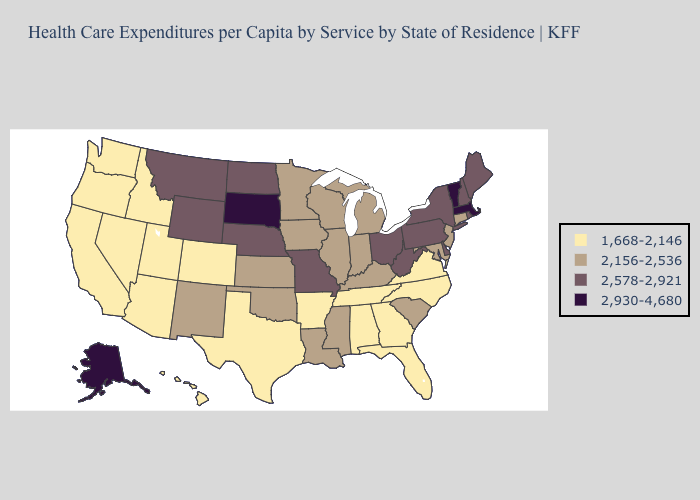Among the states that border Georgia , does South Carolina have the lowest value?
Give a very brief answer. No. What is the highest value in the USA?
Write a very short answer. 2,930-4,680. Does the first symbol in the legend represent the smallest category?
Keep it brief. Yes. Does New Jersey have the lowest value in the Northeast?
Answer briefly. Yes. Does Iowa have the lowest value in the USA?
Concise answer only. No. What is the lowest value in the USA?
Give a very brief answer. 1,668-2,146. What is the value of Oklahoma?
Write a very short answer. 2,156-2,536. What is the value of California?
Concise answer only. 1,668-2,146. Name the states that have a value in the range 1,668-2,146?
Be succinct. Alabama, Arizona, Arkansas, California, Colorado, Florida, Georgia, Hawaii, Idaho, Nevada, North Carolina, Oregon, Tennessee, Texas, Utah, Virginia, Washington. Name the states that have a value in the range 2,578-2,921?
Concise answer only. Delaware, Maine, Missouri, Montana, Nebraska, New Hampshire, New York, North Dakota, Ohio, Pennsylvania, Rhode Island, West Virginia, Wyoming. What is the highest value in the USA?
Keep it brief. 2,930-4,680. What is the value of Oklahoma?
Concise answer only. 2,156-2,536. Which states have the lowest value in the Northeast?
Quick response, please. Connecticut, New Jersey. Name the states that have a value in the range 1,668-2,146?
Be succinct. Alabama, Arizona, Arkansas, California, Colorado, Florida, Georgia, Hawaii, Idaho, Nevada, North Carolina, Oregon, Tennessee, Texas, Utah, Virginia, Washington. 